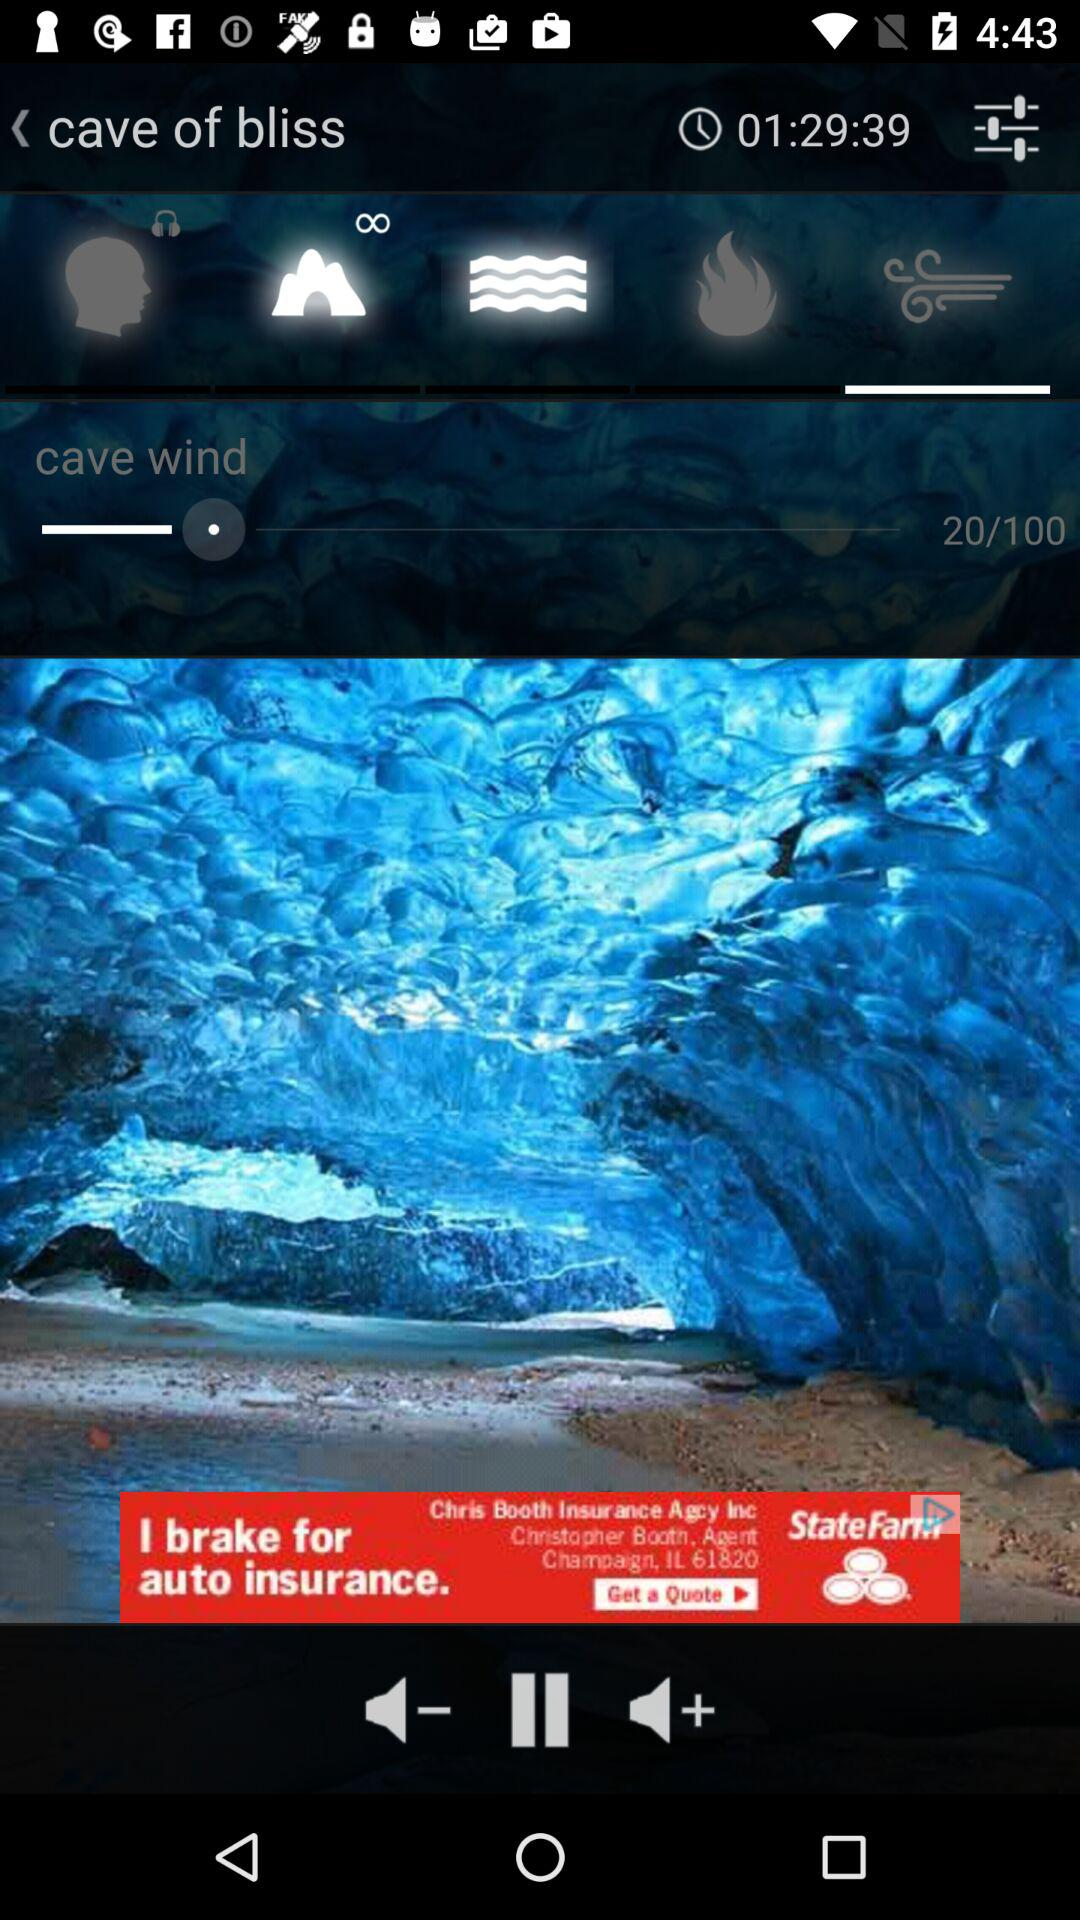What is the set cave wind? The set cave wind is 20. 